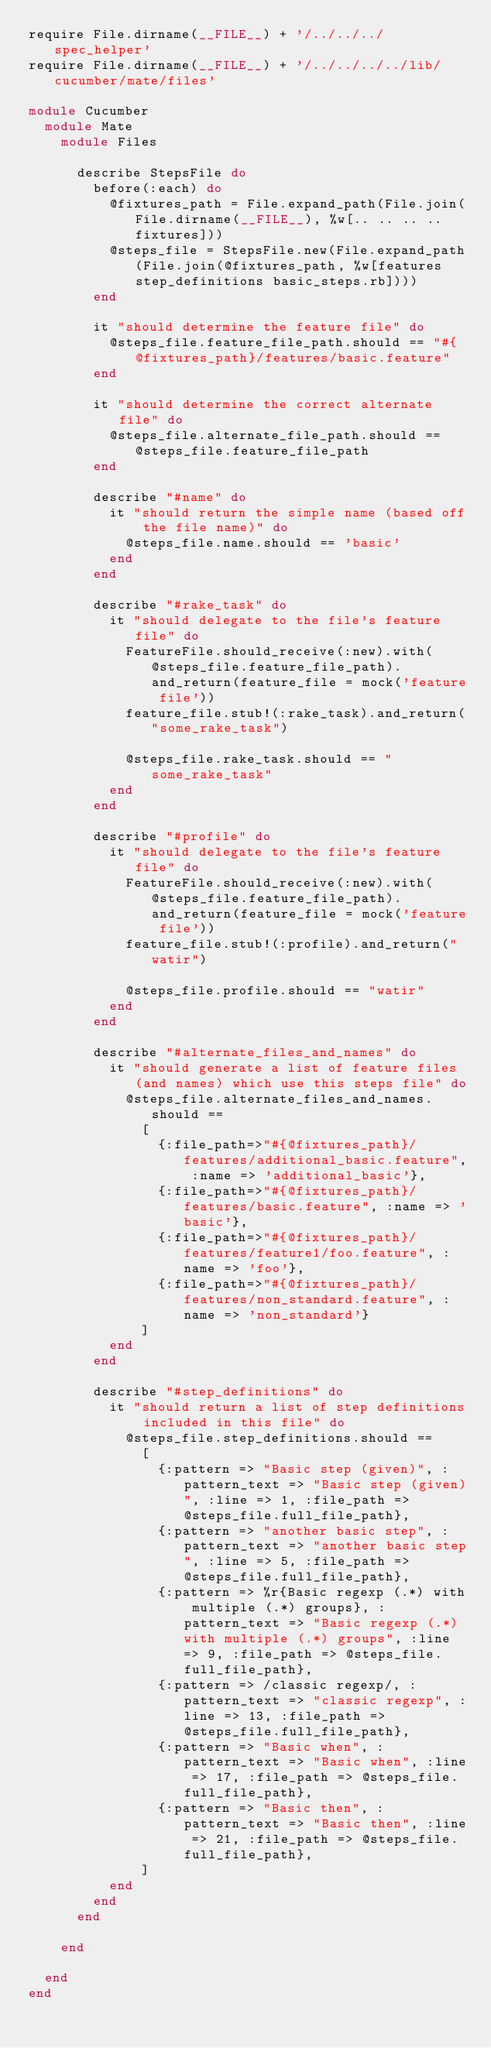Convert code to text. <code><loc_0><loc_0><loc_500><loc_500><_Ruby_>require File.dirname(__FILE__) + '/../../../spec_helper'
require File.dirname(__FILE__) + '/../../../../lib/cucumber/mate/files'

module Cucumber
  module Mate
    module Files
    
      describe StepsFile do
        before(:each) do
          @fixtures_path = File.expand_path(File.join(File.dirname(__FILE__), %w[.. .. .. .. fixtures]))
          @steps_file = StepsFile.new(File.expand_path(File.join(@fixtures_path, %w[features step_definitions basic_steps.rb])))
        end        
        
        it "should determine the feature file" do          
          @steps_file.feature_file_path.should == "#{@fixtures_path}/features/basic.feature"
        end
        
        it "should determine the correct alternate file" do
          @steps_file.alternate_file_path.should == @steps_file.feature_file_path
        end
        
        describe "#name" do
          it "should return the simple name (based off the file name)" do
            @steps_file.name.should == 'basic'
          end
        end
        
        describe "#rake_task" do
          it "should delegate to the file's feature file" do
            FeatureFile.should_receive(:new).with(@steps_file.feature_file_path).and_return(feature_file = mock('feature file'))
            feature_file.stub!(:rake_task).and_return("some_rake_task")
            
            @steps_file.rake_task.should == "some_rake_task"
          end
        end
        
        describe "#profile" do
          it "should delegate to the file's feature file" do
            FeatureFile.should_receive(:new).with(@steps_file.feature_file_path).and_return(feature_file = mock('feature file'))
            feature_file.stub!(:profile).and_return("watir")
            
            @steps_file.profile.should == "watir"
          end
        end
        
        describe "#alternate_files_and_names" do
          it "should generate a list of feature files (and names) which use this steps file" do
            @steps_file.alternate_files_and_names.should ==
              [
                {:file_path=>"#{@fixtures_path}/features/additional_basic.feature", :name => 'additional_basic'},
                {:file_path=>"#{@fixtures_path}/features/basic.feature", :name => 'basic'},
                {:file_path=>"#{@fixtures_path}/features/feature1/foo.feature", :name => 'foo'},
                {:file_path=>"#{@fixtures_path}/features/non_standard.feature", :name => 'non_standard'}
              ]
          end
        end
        
        describe "#step_definitions" do
          it "should return a list of step definitions included in this file" do
            @steps_file.step_definitions.should ==
              [
                {:pattern => "Basic step (given)", :pattern_text => "Basic step (given)", :line => 1, :file_path => @steps_file.full_file_path},
                {:pattern => "another basic step", :pattern_text => "another basic step", :line => 5, :file_path => @steps_file.full_file_path},
                {:pattern => %r{Basic regexp (.*) with multiple (.*) groups}, :pattern_text => "Basic regexp (.*) with multiple (.*) groups", :line => 9, :file_path => @steps_file.full_file_path},
                {:pattern => /classic regexp/, :pattern_text => "classic regexp", :line => 13, :file_path => @steps_file.full_file_path},
                {:pattern => "Basic when", :pattern_text => "Basic when", :line => 17, :file_path => @steps_file.full_file_path},
                {:pattern => "Basic then", :pattern_text => "Basic then", :line => 21, :file_path => @steps_file.full_file_path},
              ]
          end
        end
      end
      
    end

  end
end</code> 